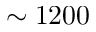<formula> <loc_0><loc_0><loc_500><loc_500>\sim 1 2 0 0</formula> 